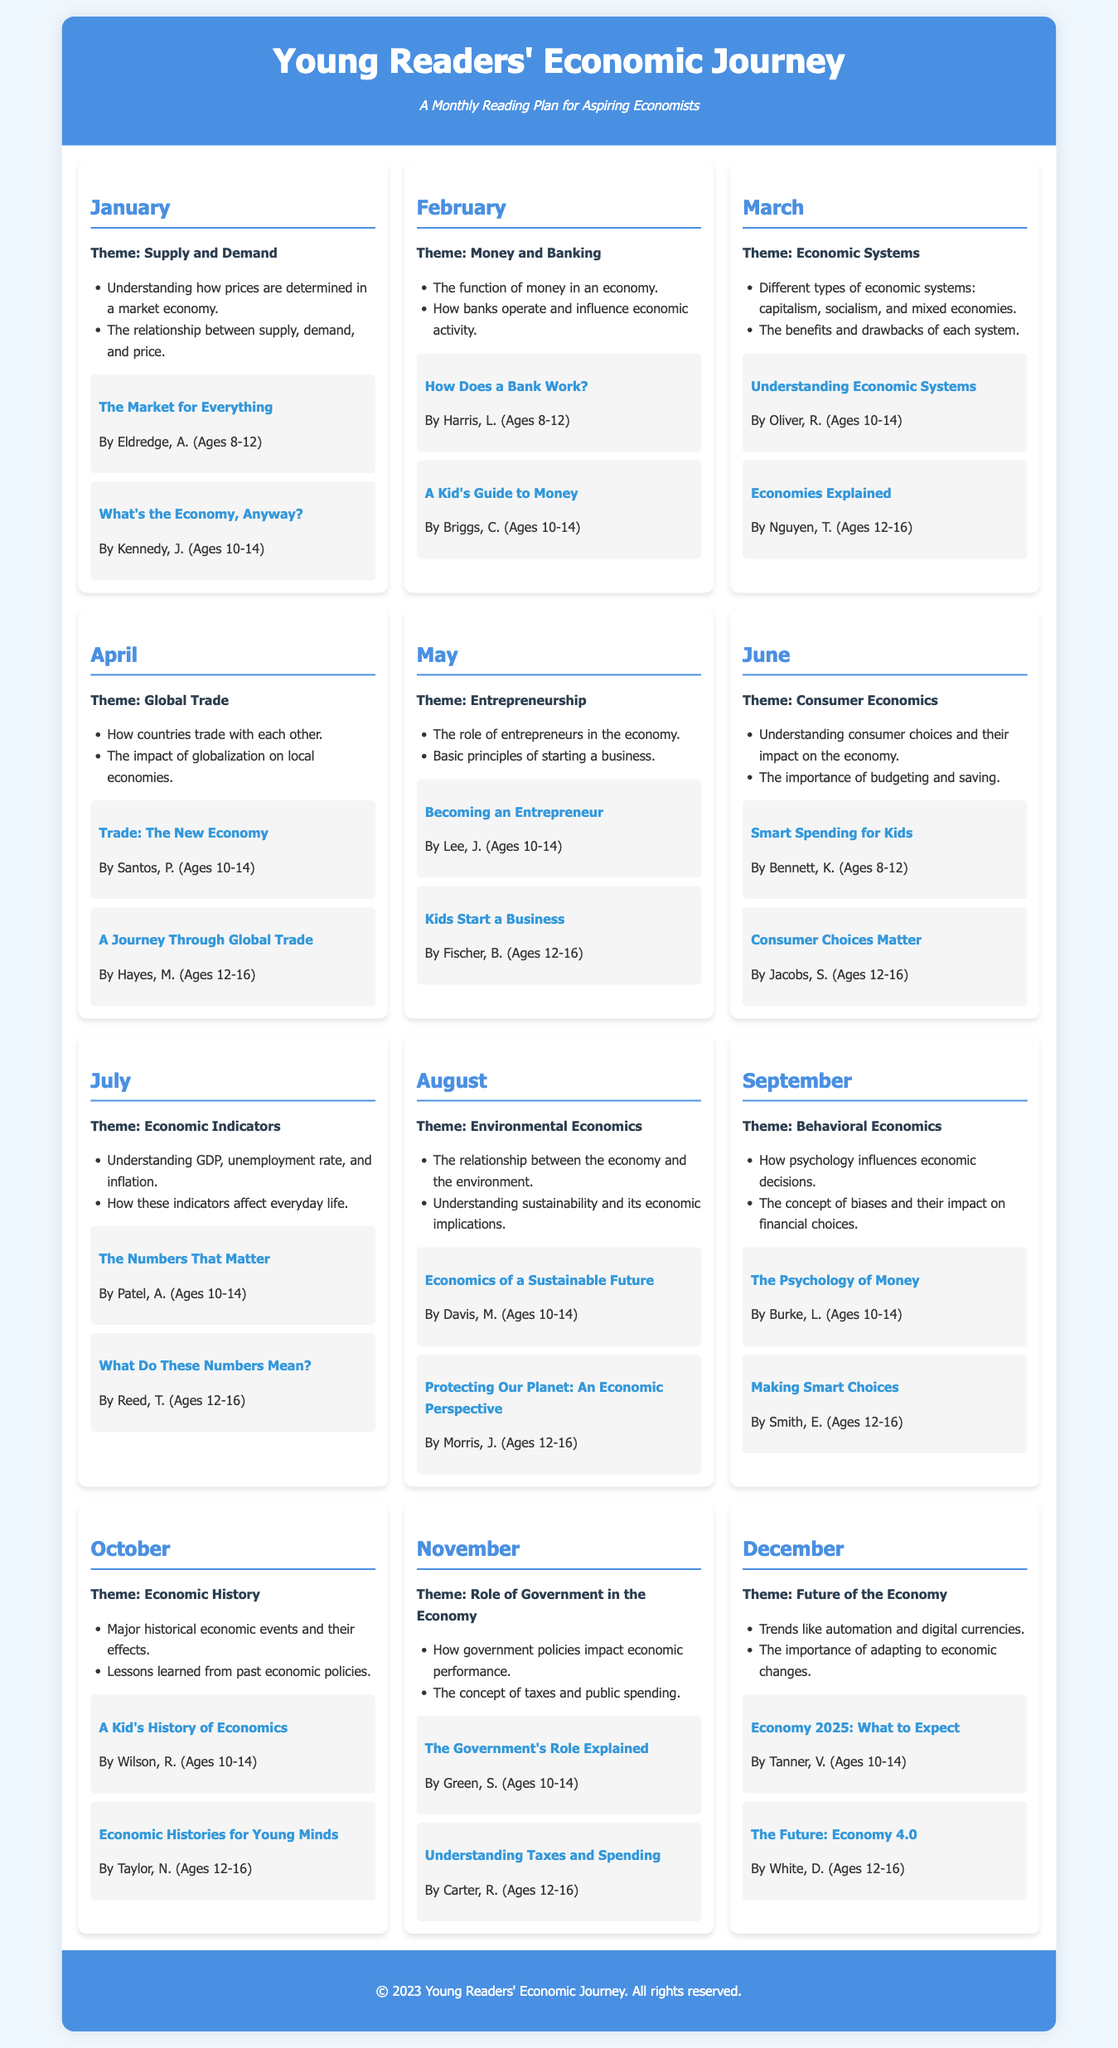What is the theme for January? The theme is listed right under January and describes the main focus for that month.
Answer: Supply and Demand How many books are recommended for April? Each month has a set number of books listed under it; in April, there are two listed.
Answer: 2 Who wrote "The Market for Everything"? The author of this book is mentioned below the title, indicating who wrote it.
Answer: Eldredge, A What is the age range for "Understanding Economic Systems"? The age range is provided alongside the book title, indicating the target audience for the book.
Answer: 10-14 Which month focuses on Consumer Economics? The month is identified by its title that describes the subject matter within it.
Answer: June What principle is explored in February? The principle is detailed in the theme section for that month, which outlines the focus.
Answer: Money and Banking In which month is the theme “Environmental Economics”? This is indicated under the month card that outlines that particular month’s focus.
Answer: August How many themes are covered in total in the document? The themes are listed across each month card, and each month has one unique theme.
Answer: 12 What are the two types of economic systems mentioned in March? The systems are included in the description of the theme for March.
Answer: capitalism, socialism What book is recommended for learning about economic indicators? The specific book related to this topic is mentioned below the corresponding month’s theme.
Answer: The Numbers That Matter 